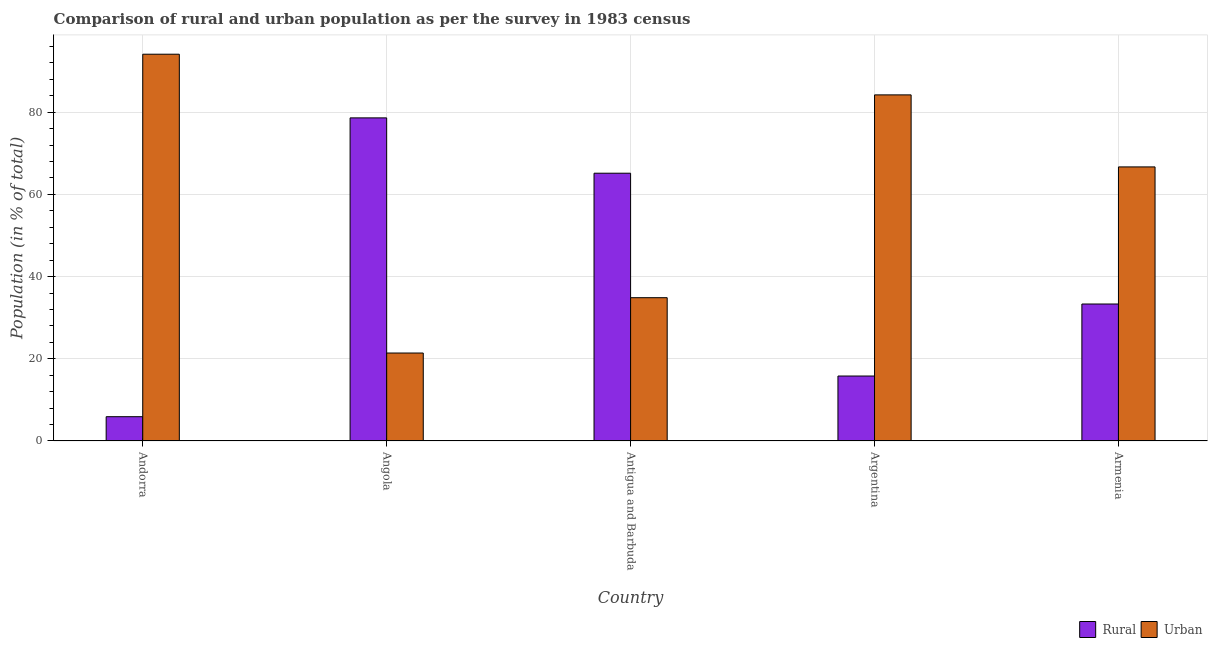How many groups of bars are there?
Ensure brevity in your answer.  5. How many bars are there on the 1st tick from the left?
Ensure brevity in your answer.  2. How many bars are there on the 4th tick from the right?
Offer a very short reply. 2. What is the rural population in Argentina?
Ensure brevity in your answer.  15.81. Across all countries, what is the maximum rural population?
Your response must be concise. 78.6. Across all countries, what is the minimum urban population?
Your answer should be very brief. 21.4. In which country was the rural population maximum?
Make the answer very short. Angola. In which country was the rural population minimum?
Give a very brief answer. Andorra. What is the total urban population in the graph?
Your response must be concise. 301.22. What is the difference between the urban population in Antigua and Barbuda and that in Armenia?
Provide a succinct answer. -31.81. What is the difference between the urban population in Antigua and Barbuda and the rural population in Andorra?
Make the answer very short. 28.95. What is the average rural population per country?
Offer a very short reply. 39.76. What is the difference between the rural population and urban population in Angola?
Your answer should be compact. 57.2. In how many countries, is the urban population greater than 32 %?
Make the answer very short. 4. What is the ratio of the urban population in Andorra to that in Antigua and Barbuda?
Your answer should be compact. 2.7. Is the difference between the urban population in Andorra and Angola greater than the difference between the rural population in Andorra and Angola?
Your answer should be very brief. Yes. What is the difference between the highest and the second highest urban population?
Make the answer very short. 9.89. What is the difference between the highest and the lowest urban population?
Ensure brevity in your answer.  72.69. What does the 2nd bar from the left in Armenia represents?
Make the answer very short. Urban. What does the 2nd bar from the right in Armenia represents?
Provide a short and direct response. Rural. How many countries are there in the graph?
Provide a short and direct response. 5. Does the graph contain any zero values?
Give a very brief answer. No. Does the graph contain grids?
Keep it short and to the point. Yes. How are the legend labels stacked?
Offer a very short reply. Horizontal. What is the title of the graph?
Your answer should be very brief. Comparison of rural and urban population as per the survey in 1983 census. What is the label or title of the X-axis?
Your response must be concise. Country. What is the label or title of the Y-axis?
Your answer should be compact. Population (in % of total). What is the Population (in % of total) of Rural in Andorra?
Keep it short and to the point. 5.91. What is the Population (in % of total) in Urban in Andorra?
Your answer should be very brief. 94.09. What is the Population (in % of total) in Rural in Angola?
Your response must be concise. 78.6. What is the Population (in % of total) of Urban in Angola?
Your response must be concise. 21.4. What is the Population (in % of total) of Rural in Antigua and Barbuda?
Provide a succinct answer. 65.14. What is the Population (in % of total) in Urban in Antigua and Barbuda?
Ensure brevity in your answer.  34.86. What is the Population (in % of total) of Rural in Argentina?
Offer a terse response. 15.81. What is the Population (in % of total) of Urban in Argentina?
Give a very brief answer. 84.19. What is the Population (in % of total) in Rural in Armenia?
Your answer should be very brief. 33.33. What is the Population (in % of total) in Urban in Armenia?
Give a very brief answer. 66.67. Across all countries, what is the maximum Population (in % of total) in Rural?
Ensure brevity in your answer.  78.6. Across all countries, what is the maximum Population (in % of total) in Urban?
Ensure brevity in your answer.  94.09. Across all countries, what is the minimum Population (in % of total) in Rural?
Give a very brief answer. 5.91. Across all countries, what is the minimum Population (in % of total) of Urban?
Offer a very short reply. 21.4. What is the total Population (in % of total) in Rural in the graph?
Provide a succinct answer. 198.78. What is the total Population (in % of total) in Urban in the graph?
Provide a succinct answer. 301.22. What is the difference between the Population (in % of total) of Rural in Andorra and that in Angola?
Keep it short and to the point. -72.69. What is the difference between the Population (in % of total) of Urban in Andorra and that in Angola?
Make the answer very short. 72.69. What is the difference between the Population (in % of total) in Rural in Andorra and that in Antigua and Barbuda?
Provide a short and direct response. -59.23. What is the difference between the Population (in % of total) in Urban in Andorra and that in Antigua and Barbuda?
Make the answer very short. 59.23. What is the difference between the Population (in % of total) of Rural in Andorra and that in Argentina?
Provide a succinct answer. -9.89. What is the difference between the Population (in % of total) of Urban in Andorra and that in Argentina?
Offer a very short reply. 9.89. What is the difference between the Population (in % of total) of Rural in Andorra and that in Armenia?
Offer a terse response. -27.41. What is the difference between the Population (in % of total) of Urban in Andorra and that in Armenia?
Offer a very short reply. 27.41. What is the difference between the Population (in % of total) in Rural in Angola and that in Antigua and Barbuda?
Offer a terse response. 13.46. What is the difference between the Population (in % of total) in Urban in Angola and that in Antigua and Barbuda?
Make the answer very short. -13.46. What is the difference between the Population (in % of total) of Rural in Angola and that in Argentina?
Your response must be concise. 62.8. What is the difference between the Population (in % of total) of Urban in Angola and that in Argentina?
Ensure brevity in your answer.  -62.8. What is the difference between the Population (in % of total) of Rural in Angola and that in Armenia?
Ensure brevity in your answer.  45.28. What is the difference between the Population (in % of total) in Urban in Angola and that in Armenia?
Your response must be concise. -45.28. What is the difference between the Population (in % of total) in Rural in Antigua and Barbuda and that in Argentina?
Provide a succinct answer. 49.33. What is the difference between the Population (in % of total) of Urban in Antigua and Barbuda and that in Argentina?
Keep it short and to the point. -49.33. What is the difference between the Population (in % of total) of Rural in Antigua and Barbuda and that in Armenia?
Offer a very short reply. 31.82. What is the difference between the Population (in % of total) in Urban in Antigua and Barbuda and that in Armenia?
Your answer should be compact. -31.82. What is the difference between the Population (in % of total) in Rural in Argentina and that in Armenia?
Offer a very short reply. -17.52. What is the difference between the Population (in % of total) of Urban in Argentina and that in Armenia?
Offer a very short reply. 17.52. What is the difference between the Population (in % of total) in Rural in Andorra and the Population (in % of total) in Urban in Angola?
Your answer should be very brief. -15.49. What is the difference between the Population (in % of total) in Rural in Andorra and the Population (in % of total) in Urban in Antigua and Barbuda?
Your response must be concise. -28.95. What is the difference between the Population (in % of total) in Rural in Andorra and the Population (in % of total) in Urban in Argentina?
Offer a very short reply. -78.28. What is the difference between the Population (in % of total) in Rural in Andorra and the Population (in % of total) in Urban in Armenia?
Offer a very short reply. -60.76. What is the difference between the Population (in % of total) of Rural in Angola and the Population (in % of total) of Urban in Antigua and Barbuda?
Your response must be concise. 43.74. What is the difference between the Population (in % of total) of Rural in Angola and the Population (in % of total) of Urban in Argentina?
Make the answer very short. -5.59. What is the difference between the Population (in % of total) in Rural in Angola and the Population (in % of total) in Urban in Armenia?
Your answer should be very brief. 11.93. What is the difference between the Population (in % of total) of Rural in Antigua and Barbuda and the Population (in % of total) of Urban in Argentina?
Offer a terse response. -19.05. What is the difference between the Population (in % of total) of Rural in Antigua and Barbuda and the Population (in % of total) of Urban in Armenia?
Keep it short and to the point. -1.53. What is the difference between the Population (in % of total) in Rural in Argentina and the Population (in % of total) in Urban in Armenia?
Provide a succinct answer. -50.87. What is the average Population (in % of total) of Rural per country?
Make the answer very short. 39.76. What is the average Population (in % of total) in Urban per country?
Offer a very short reply. 60.24. What is the difference between the Population (in % of total) in Rural and Population (in % of total) in Urban in Andorra?
Your response must be concise. -88.18. What is the difference between the Population (in % of total) of Rural and Population (in % of total) of Urban in Angola?
Your answer should be very brief. 57.2. What is the difference between the Population (in % of total) of Rural and Population (in % of total) of Urban in Antigua and Barbuda?
Provide a succinct answer. 30.28. What is the difference between the Population (in % of total) of Rural and Population (in % of total) of Urban in Argentina?
Provide a short and direct response. -68.39. What is the difference between the Population (in % of total) in Rural and Population (in % of total) in Urban in Armenia?
Ensure brevity in your answer.  -33.35. What is the ratio of the Population (in % of total) in Rural in Andorra to that in Angola?
Provide a short and direct response. 0.08. What is the ratio of the Population (in % of total) of Urban in Andorra to that in Angola?
Provide a short and direct response. 4.4. What is the ratio of the Population (in % of total) in Rural in Andorra to that in Antigua and Barbuda?
Keep it short and to the point. 0.09. What is the ratio of the Population (in % of total) of Urban in Andorra to that in Antigua and Barbuda?
Your response must be concise. 2.7. What is the ratio of the Population (in % of total) of Rural in Andorra to that in Argentina?
Provide a succinct answer. 0.37. What is the ratio of the Population (in % of total) of Urban in Andorra to that in Argentina?
Make the answer very short. 1.12. What is the ratio of the Population (in % of total) of Rural in Andorra to that in Armenia?
Offer a very short reply. 0.18. What is the ratio of the Population (in % of total) of Urban in Andorra to that in Armenia?
Provide a short and direct response. 1.41. What is the ratio of the Population (in % of total) in Rural in Angola to that in Antigua and Barbuda?
Offer a very short reply. 1.21. What is the ratio of the Population (in % of total) in Urban in Angola to that in Antigua and Barbuda?
Make the answer very short. 0.61. What is the ratio of the Population (in % of total) in Rural in Angola to that in Argentina?
Your response must be concise. 4.97. What is the ratio of the Population (in % of total) of Urban in Angola to that in Argentina?
Give a very brief answer. 0.25. What is the ratio of the Population (in % of total) in Rural in Angola to that in Armenia?
Provide a short and direct response. 2.36. What is the ratio of the Population (in % of total) of Urban in Angola to that in Armenia?
Provide a short and direct response. 0.32. What is the ratio of the Population (in % of total) of Rural in Antigua and Barbuda to that in Argentina?
Keep it short and to the point. 4.12. What is the ratio of the Population (in % of total) in Urban in Antigua and Barbuda to that in Argentina?
Offer a very short reply. 0.41. What is the ratio of the Population (in % of total) in Rural in Antigua and Barbuda to that in Armenia?
Your answer should be compact. 1.95. What is the ratio of the Population (in % of total) in Urban in Antigua and Barbuda to that in Armenia?
Give a very brief answer. 0.52. What is the ratio of the Population (in % of total) in Rural in Argentina to that in Armenia?
Keep it short and to the point. 0.47. What is the ratio of the Population (in % of total) of Urban in Argentina to that in Armenia?
Offer a terse response. 1.26. What is the difference between the highest and the second highest Population (in % of total) in Rural?
Keep it short and to the point. 13.46. What is the difference between the highest and the second highest Population (in % of total) in Urban?
Your answer should be very brief. 9.89. What is the difference between the highest and the lowest Population (in % of total) in Rural?
Your answer should be very brief. 72.69. What is the difference between the highest and the lowest Population (in % of total) of Urban?
Your answer should be very brief. 72.69. 